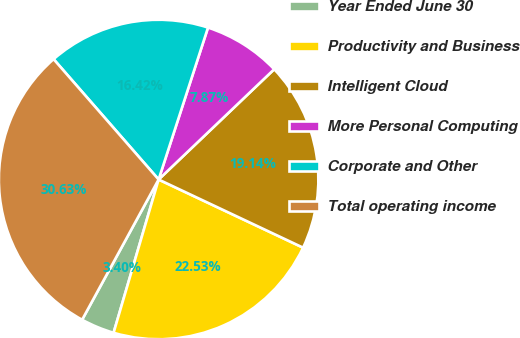Convert chart. <chart><loc_0><loc_0><loc_500><loc_500><pie_chart><fcel>Year Ended June 30<fcel>Productivity and Business<fcel>Intelligent Cloud<fcel>More Personal Computing<fcel>Corporate and Other<fcel>Total operating income<nl><fcel>3.4%<fcel>22.53%<fcel>19.14%<fcel>7.87%<fcel>16.42%<fcel>30.63%<nl></chart> 